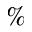Convert formula to latex. <formula><loc_0><loc_0><loc_500><loc_500>\%</formula> 